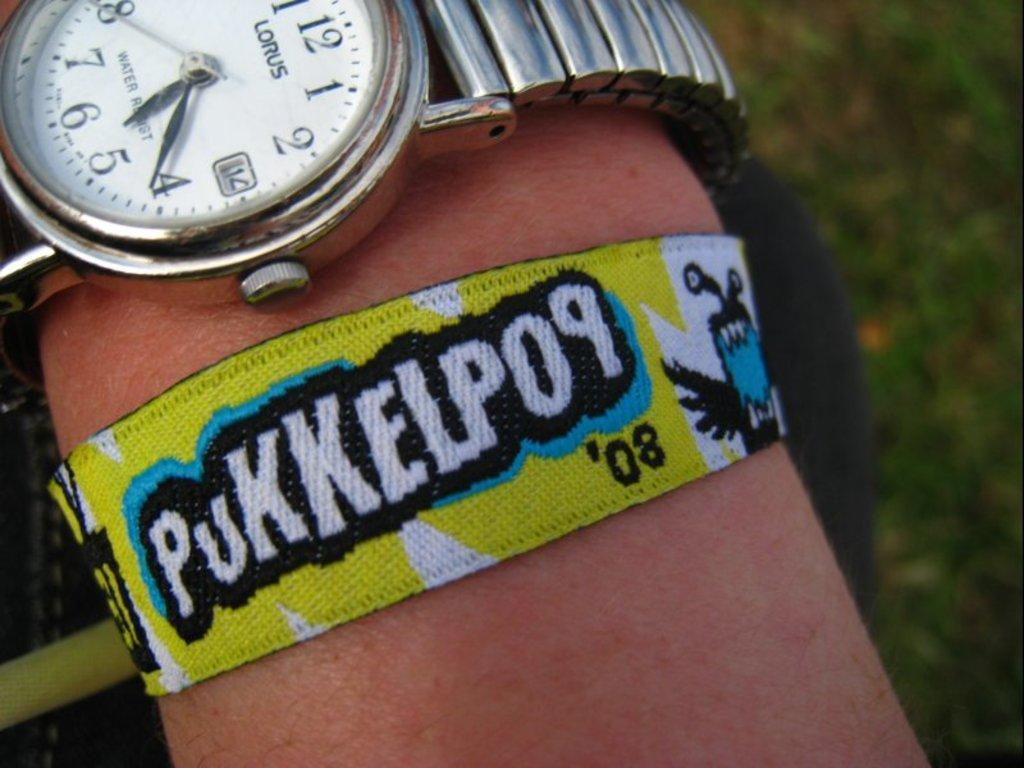<image>
Create a compact narrative representing the image presented. A wrist band with Pukkelpop written on it. 